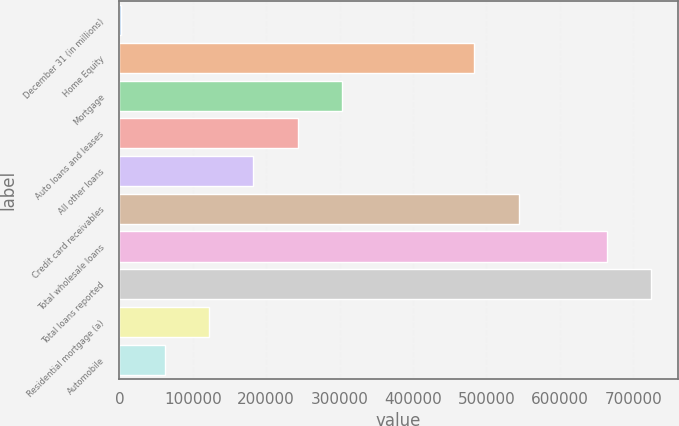Convert chart to OTSL. <chart><loc_0><loc_0><loc_500><loc_500><bar_chart><fcel>December 31 (in millions)<fcel>Home Equity<fcel>Mortgage<fcel>Auto loans and leases<fcel>All other loans<fcel>Credit card receivables<fcel>Total wholesale loans<fcel>Total loans reported<fcel>Residential mortgage (a)<fcel>Automobile<nl><fcel>2006<fcel>483586<fcel>302994<fcel>242796<fcel>182598<fcel>543784<fcel>664178<fcel>724376<fcel>122401<fcel>62203.5<nl></chart> 